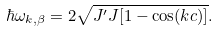Convert formula to latex. <formula><loc_0><loc_0><loc_500><loc_500>\hbar { \omega } _ { k , \beta } = 2 \sqrt { J ^ { \prime } J [ 1 - \cos ( k c ) ] } .</formula> 